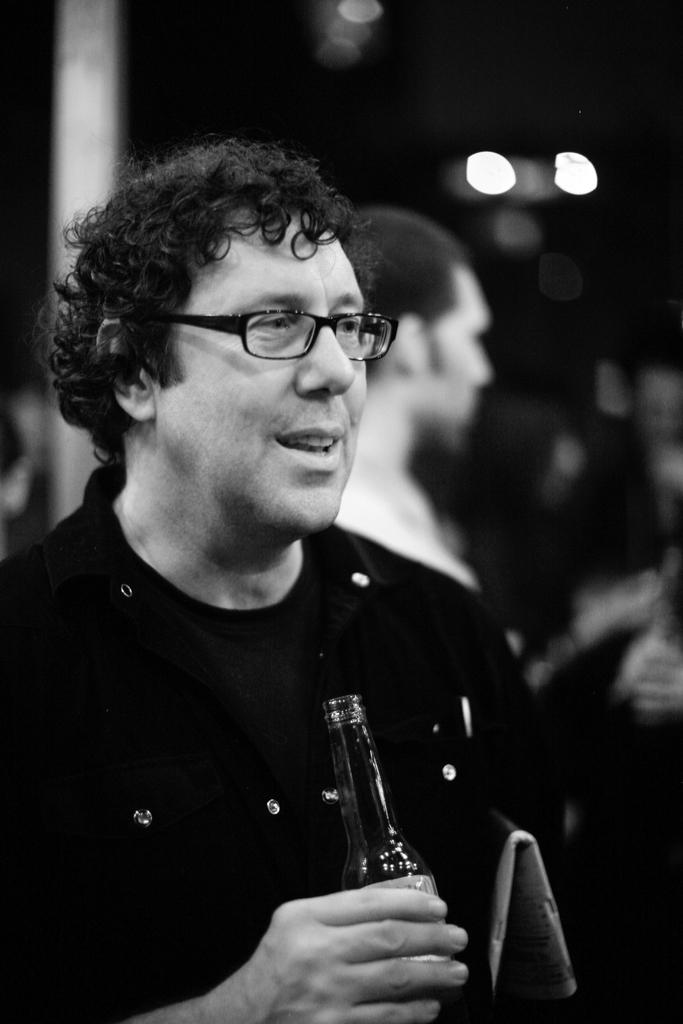Who is present in the image? There is a man in the image. What is the man doing in the image? The man is standing in the image. What object is the man holding in his hand? The man is holding a wine glass in his hand. What is the color scheme of the image? The image is in black and white color. What type of star can be seen in the image? There is no star visible in the image, as it is in black and white color and does not depict celestial objects. 